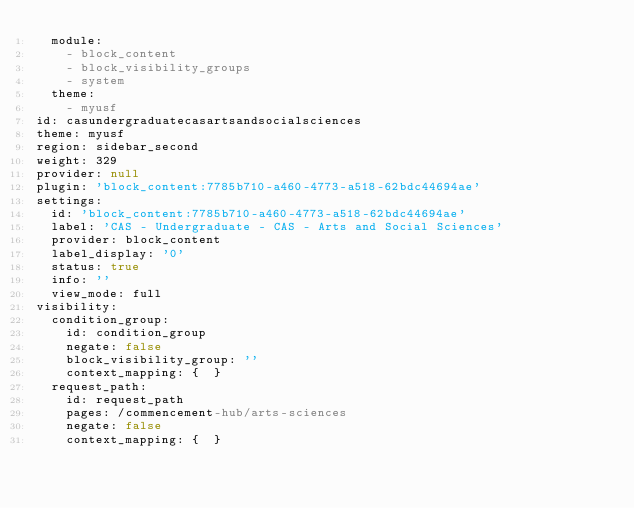<code> <loc_0><loc_0><loc_500><loc_500><_YAML_>  module:
    - block_content
    - block_visibility_groups
    - system
  theme:
    - myusf
id: casundergraduatecasartsandsocialsciences
theme: myusf
region: sidebar_second
weight: 329
provider: null
plugin: 'block_content:7785b710-a460-4773-a518-62bdc44694ae'
settings:
  id: 'block_content:7785b710-a460-4773-a518-62bdc44694ae'
  label: 'CAS - Undergraduate - CAS - Arts and Social Sciences'
  provider: block_content
  label_display: '0'
  status: true
  info: ''
  view_mode: full
visibility:
  condition_group:
    id: condition_group
    negate: false
    block_visibility_group: ''
    context_mapping: {  }
  request_path:
    id: request_path
    pages: /commencement-hub/arts-sciences
    negate: false
    context_mapping: {  }
</code> 